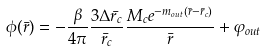<formula> <loc_0><loc_0><loc_500><loc_500>\phi ( \bar { r } ) = - \frac { \beta } { 4 \pi } \frac { 3 \Delta \bar { r } _ { c } } { \bar { r } _ { c } } \frac { M _ { c } e ^ { - m _ { o u t } ( \bar { r } - \bar { r } _ { c } ) } } { \bar { r } } + \varphi _ { o u t }</formula> 